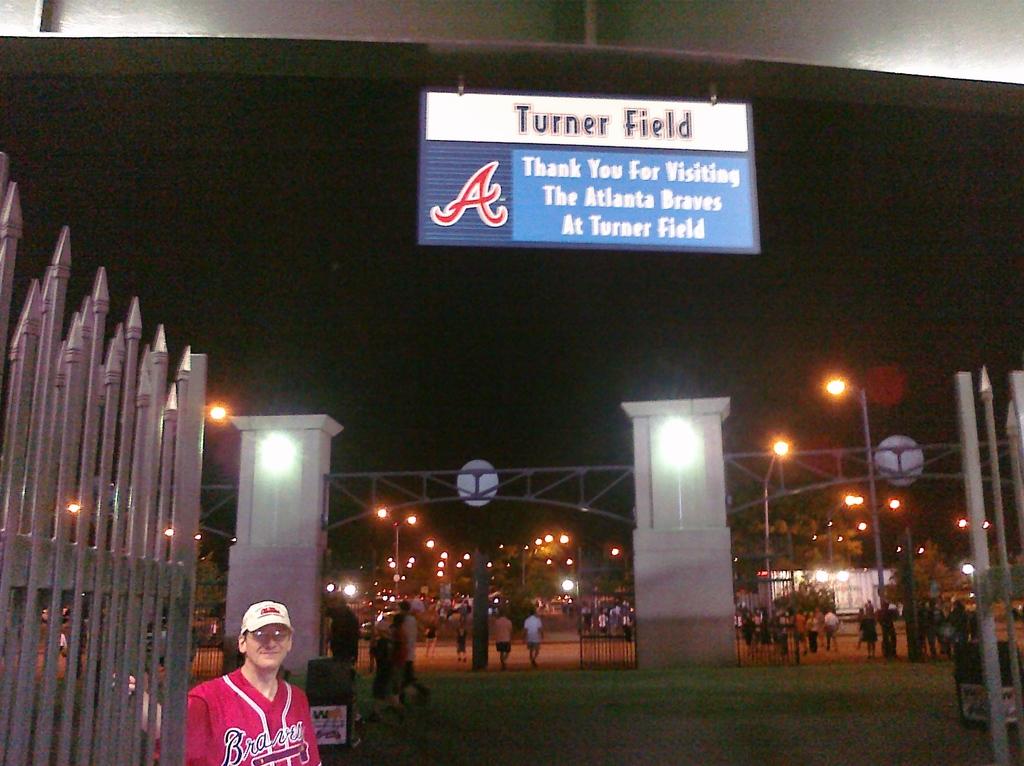What does the sign say?
Offer a very short reply. Turner field. 